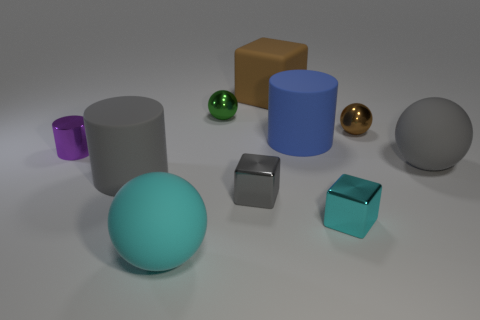Subtract all rubber cylinders. How many cylinders are left? 1 Subtract all cyan cubes. How many cubes are left? 2 Subtract 1 cubes. How many cubes are left? 2 Subtract all blocks. How many objects are left? 7 Subtract all green spheres. Subtract all green cylinders. How many spheres are left? 3 Subtract all blue objects. Subtract all brown objects. How many objects are left? 7 Add 7 large brown objects. How many large brown objects are left? 8 Add 9 brown metallic objects. How many brown metallic objects exist? 10 Subtract 0 yellow cubes. How many objects are left? 10 